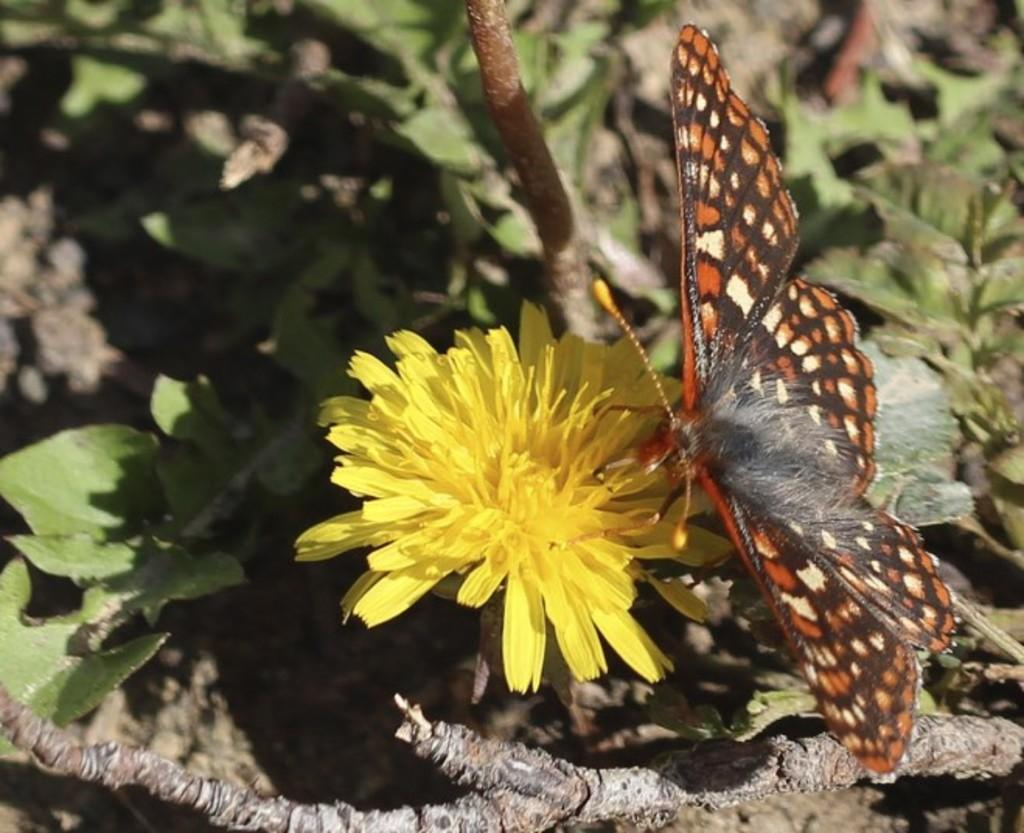What is the main subject of the image? There is a butterfly in the image. Where is the butterfly located? The butterfly is on a flower. Can you describe the colors of the butterfly? The butterfly has brown and cream colors. What color is the flower the butterfly is on? The flower has a yellow color. What can be seen in the background of the image? There are plants in the background of the image. What color are the plants in the background? The plants have a green color. How many ladybugs are sitting on the yam in the image? There are no ladybugs or yams present in the image. What type of work does the secretary do in the image? There is no secretary present in the image. 